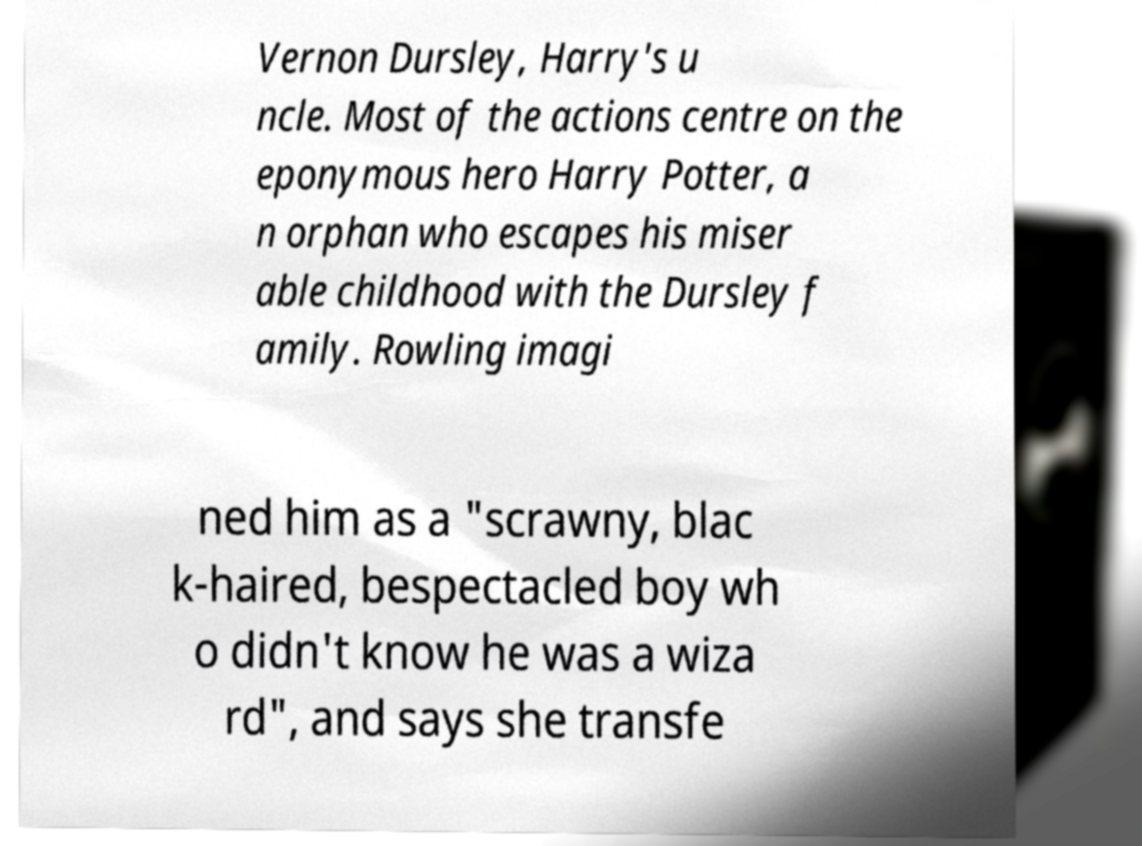There's text embedded in this image that I need extracted. Can you transcribe it verbatim? Vernon Dursley, Harry's u ncle. Most of the actions centre on the eponymous hero Harry Potter, a n orphan who escapes his miser able childhood with the Dursley f amily. Rowling imagi ned him as a "scrawny, blac k-haired, bespectacled boy wh o didn't know he was a wiza rd", and says she transfe 